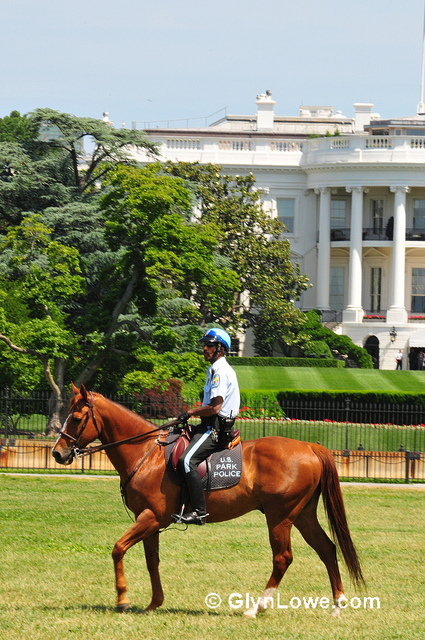Extract all visible text content from this image. U.S. PARK POLICE c GlynLowe.com 